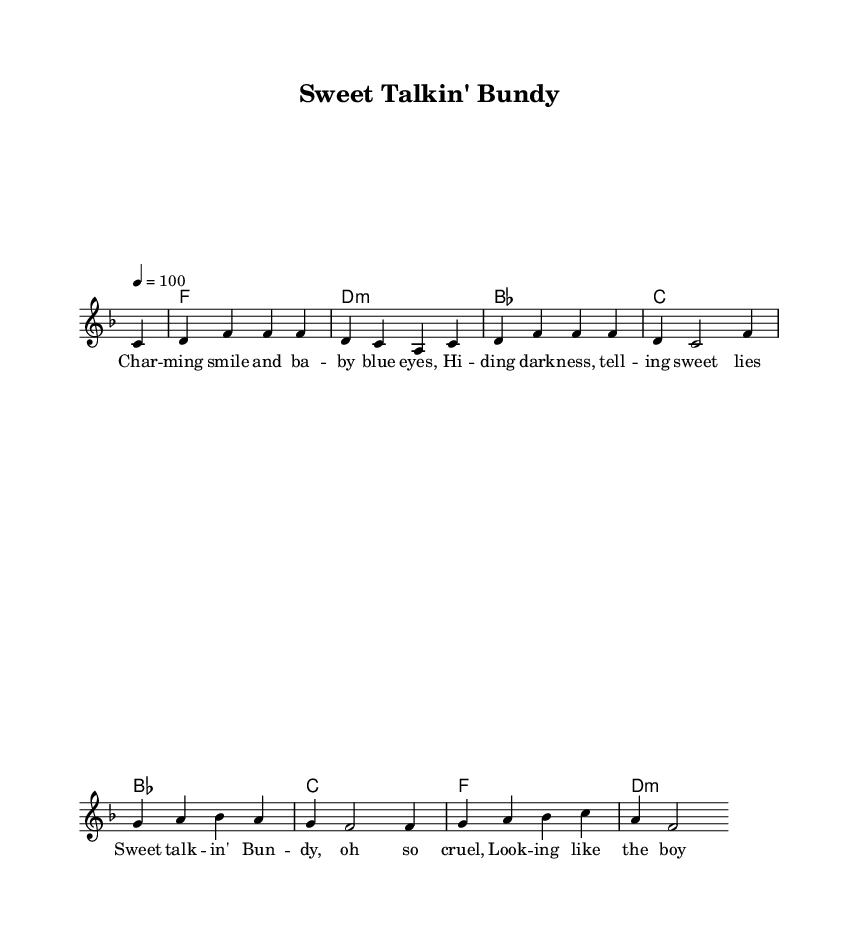What is the key signature of this music? The key signature is F major, which has one flat (B flat). This can be found at the beginning of the staff indicated by the placement of the flat sign.
Answer: F major What is the time signature of this music? The time signature is 4/4, indicated at the beginning of the music. This means there are four beats in a measure, and the quarter note gets one beat.
Answer: 4/4 What is the tempo marking of the piece? The tempo marking is 100, indicated with "4 = 100" in the global settings. This denotes the pace at which the music should be played.
Answer: 100 How many measures are in the melody? The melody section contains 8 measures, which can be counted from the beginning to the end of the melody part, represented by the bar lines.
Answer: 8 Which chord is played on the first measure? The first measure contains the chord F major, which is indicated by the chord names below the staff.
Answer: F What is the lyrical theme of the song represented in this sheet music? The theme revolves around a charming yet sinister character, as depicted in the lyrics "Sweet talkin' Bundy, oh so cruel," aligning with the context of infamous serial killers, reflecting on the duality of allure and danger.
Answer: Serial killers How does the rhythmic structure support the lyrical content? The rhythmic structure follows a steady 4/4 time signature, which provides a danceable and engaging groove typical of Rhythm and Blues, complementing the storytelling aspect of the lyrics about charm and deception while maintaining an ominous undertone.
Answer: Danceable groove 